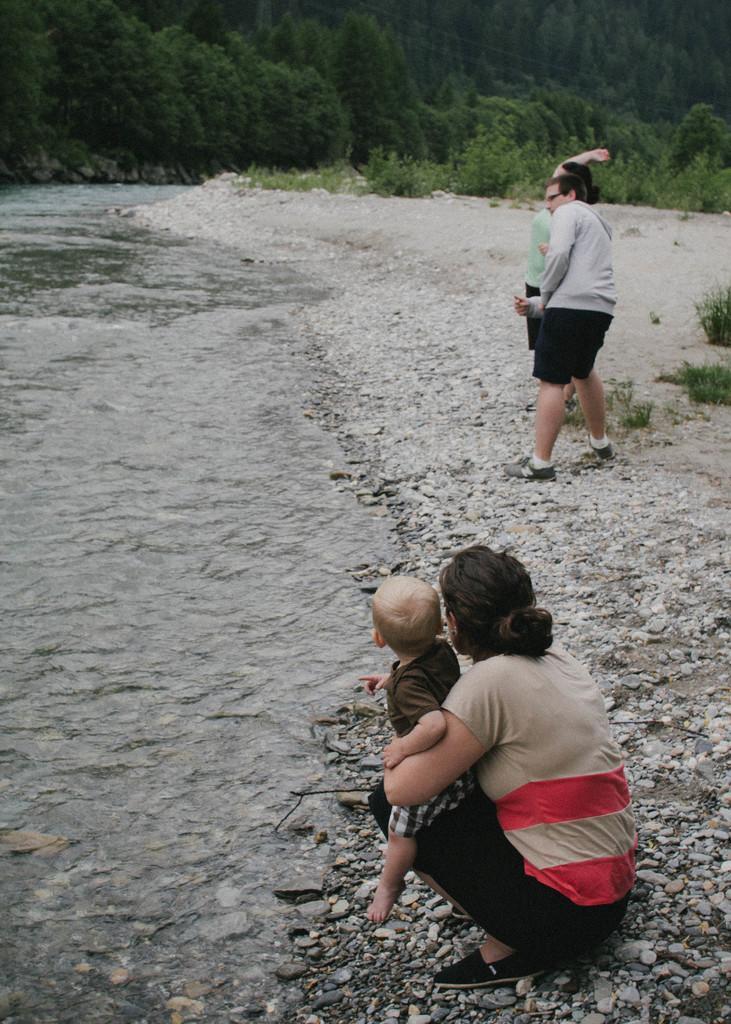In one or two sentences, can you explain what this image depicts? At the bottom of the image we can see a lady is sitting on her knees and holding a kid. On the right side of the image we can see two persons are standing. In the background of the image we can see the water, stones and some plants. At the top of the image we can see the trees. 